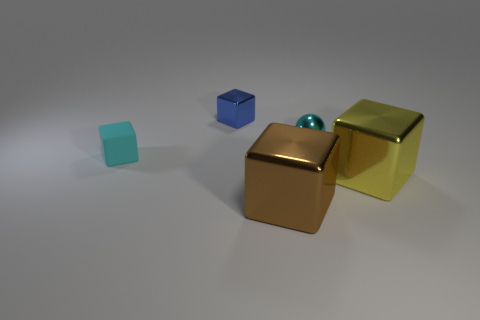What number of other things are the same color as the small matte block?
Make the answer very short. 1. There is another tiny rubber thing that is the same shape as the yellow thing; what is its color?
Keep it short and to the point. Cyan. What is the material of the object that is the same color as the tiny matte block?
Provide a short and direct response. Metal. Is the size of the yellow cube to the right of the brown shiny block the same as the shiny block that is in front of the big yellow metal block?
Keep it short and to the point. Yes. What is the size of the cyan thing that is right of the big brown object?
Your answer should be very brief. Small. Is there a thing of the same color as the metal ball?
Your answer should be very brief. Yes. Are there any large brown metal objects behind the large shiny object left of the yellow thing?
Your answer should be compact. No. Do the blue cube and the cyan thing to the left of the brown block have the same size?
Offer a terse response. Yes. There is a large shiny thing that is in front of the big cube behind the brown block; are there any small cyan things that are on the right side of it?
Offer a terse response. Yes. There is a cyan object that is in front of the cyan metallic sphere; what is its material?
Offer a very short reply. Rubber. 